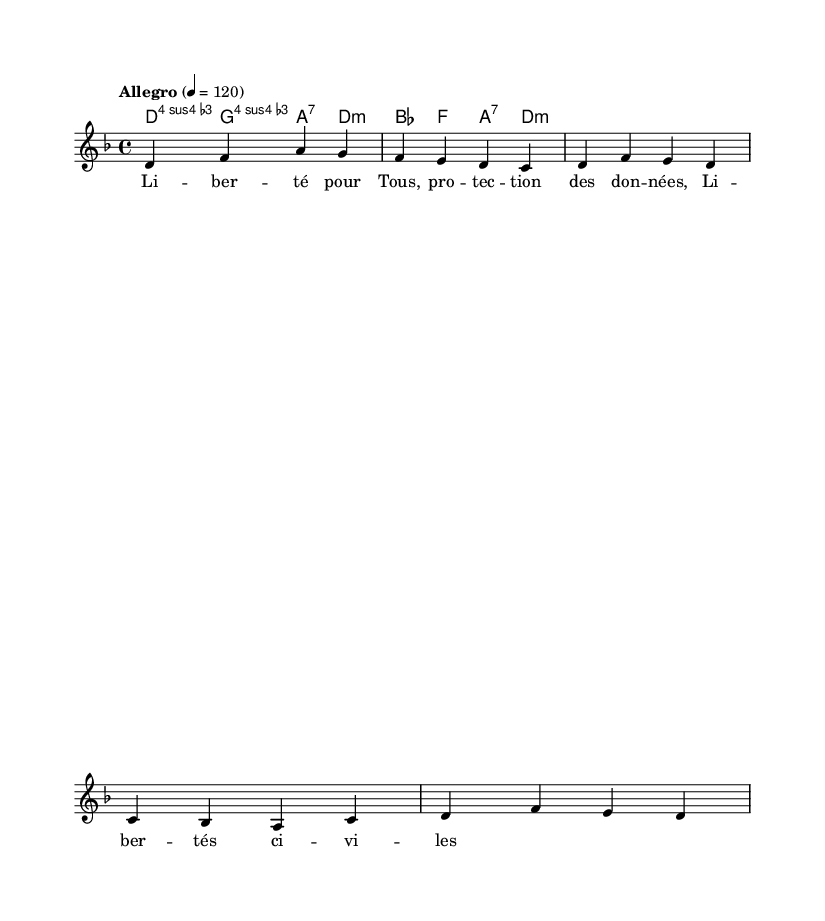What is the key signature of this music? The key signature is D minor, indicated by one flat (B flat). The key is defined at the beginning of the staff.
Answer: D minor What is the time signature of this music? The time signature is 4/4, which is noted at the beginning of the sheet music. This means there are four beats in each measure.
Answer: 4/4 What is the tempo marking for this piece? The tempo marking is "Allegro," which typically indicates a fast and lively tempo. The specific tempo is marked as 120 beats per minute.
Answer: Allegro How many measures are in the melody? The melody spans six measures, as indicated by the notation which shows a complete set of measures.
Answer: Six measures What is the first chord used in the harmony? The first chord used is a D minor chord (referred to as d:m), indicated at the beginning of the harmony section.
Answer: D minor How many syllables are in the first lyric line? The first lyric line has eight syllables ("Li -- ber -- té pour Tous, pro -- tec -- tion des don -- nées"). By counting the syllables, we arrive at the total.
Answer: Eight syllables What themes are addressed in the lyrics? The lyrics address themes of liberty and civil rights, specifically mentioning freedom ("Li -- ber -- té") and civil liberties ("Li -- ber -- tés ci -- vi -- les").
Answer: Liberty and civil rights 